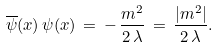Convert formula to latex. <formula><loc_0><loc_0><loc_500><loc_500>\overline { \psi } ( x ) \, \psi ( x ) \, = \, - \, \frac { m ^ { 2 } } { 2 \, \lambda } \, = \, \frac { | m ^ { 2 } | } { 2 \, \lambda } .</formula> 